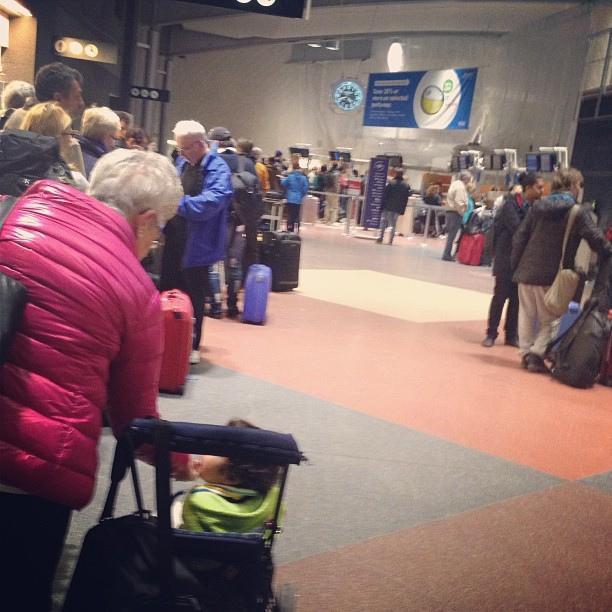How many suitcases are in the photo?
Give a very brief answer. 2. How many people can you see?
Give a very brief answer. 7. How many different types of donuts are shown?
Give a very brief answer. 0. 